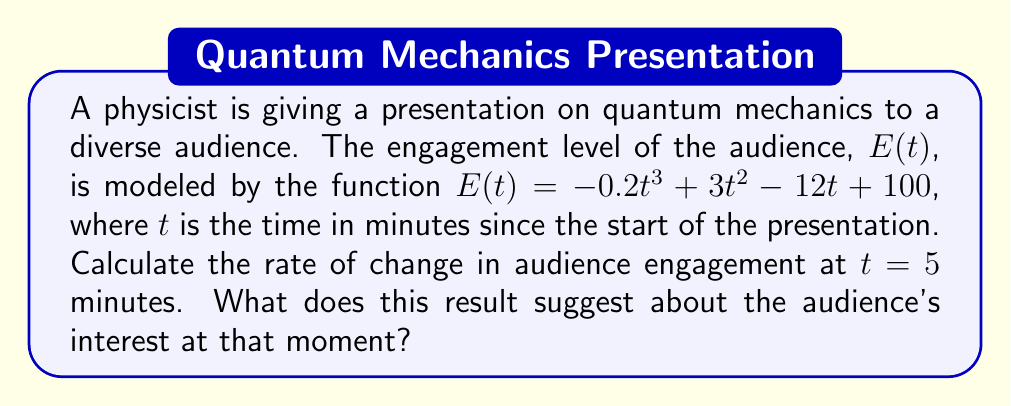Provide a solution to this math problem. To solve this problem, we need to find the derivative of the engagement function $E(t)$ and evaluate it at $t = 5$ minutes. This will give us the instantaneous rate of change in audience engagement at that specific time.

1) First, let's find the derivative of $E(t)$:
   $$E(t) = -0.2t^3 + 3t^2 - 12t + 100$$
   $$E'(t) = -0.6t^2 + 6t - 12$$

2) Now, we need to evaluate $E'(t)$ at $t = 5$:
   $$E'(5) = -0.6(5^2) + 6(5) - 12$$
   $$= -0.6(25) + 30 - 12$$
   $$= -15 + 30 - 12$$
   $$= 3$$

3) Interpreting the result:
   The rate of change at $t = 5$ minutes is 3 units per minute. This positive value indicates that the audience engagement is increasing at this point in time.

As a communication expert, you could interpret this result for the physicist:
The positive rate of change suggests that the audience's interest is growing 5 minutes into the presentation. This could be a good time for the physicist to introduce more complex concepts or interactive elements to capitalize on the increasing engagement.
Answer: The rate of change in audience engagement at $t = 5$ minutes is 3 units per minute, indicating increasing audience interest at that moment. 